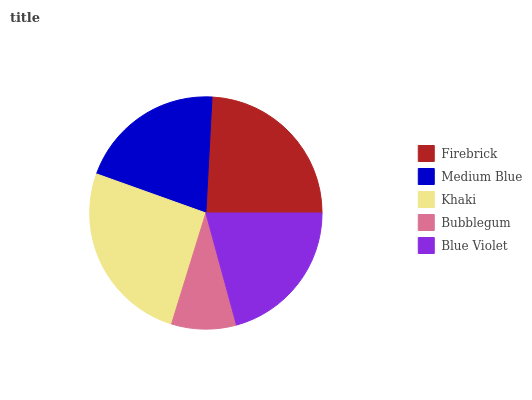Is Bubblegum the minimum?
Answer yes or no. Yes. Is Khaki the maximum?
Answer yes or no. Yes. Is Medium Blue the minimum?
Answer yes or no. No. Is Medium Blue the maximum?
Answer yes or no. No. Is Firebrick greater than Medium Blue?
Answer yes or no. Yes. Is Medium Blue less than Firebrick?
Answer yes or no. Yes. Is Medium Blue greater than Firebrick?
Answer yes or no. No. Is Firebrick less than Medium Blue?
Answer yes or no. No. Is Blue Violet the high median?
Answer yes or no. Yes. Is Blue Violet the low median?
Answer yes or no. Yes. Is Bubblegum the high median?
Answer yes or no. No. Is Bubblegum the low median?
Answer yes or no. No. 